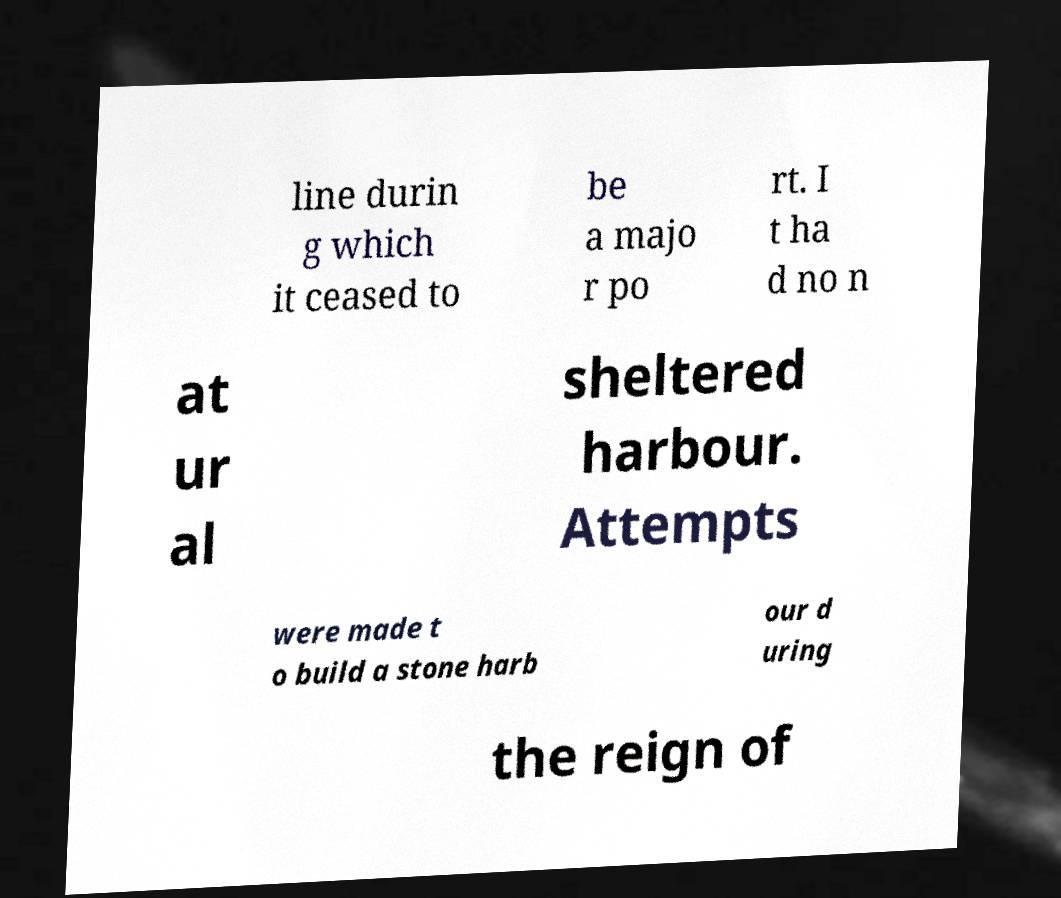I need the written content from this picture converted into text. Can you do that? line durin g which it ceased to be a majo r po rt. I t ha d no n at ur al sheltered harbour. Attempts were made t o build a stone harb our d uring the reign of 